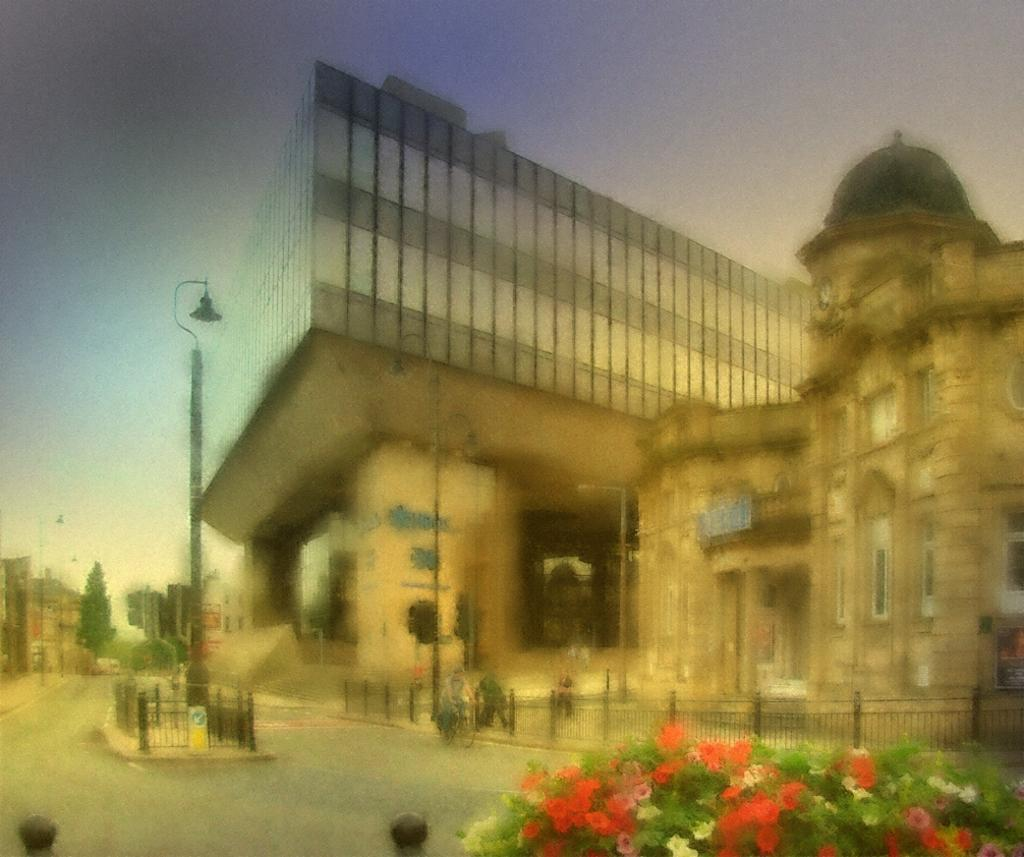What type of vegetation is at the bottom of the image? There are flower plants at the bottom of the image. What structures are located in the middle of the image? There are buildings in the middle of the image. What is visible at the top of the image? The sky is visible at the top of the image. Can you see any islands in the image? There is no island present in the image. What type of precipitation is falling from the sky in the image? The image does not show any precipitation, so it cannot be determined if sleet is falling. 